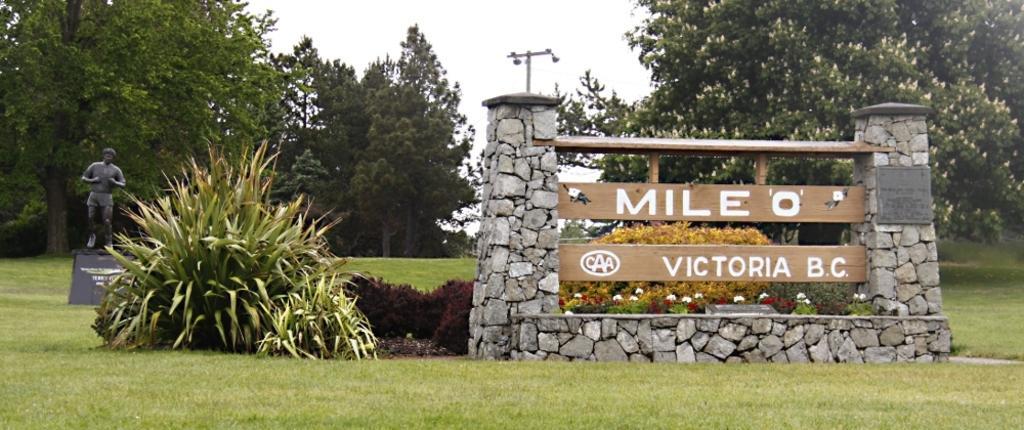Describe this image in one or two sentences. In this image there is a board between the two stone pillars. On the left side there is a statue. In the background there are trees and there is an electric pole in the middle. On the ground there are small plants and flower plants. It looks like a garden. 